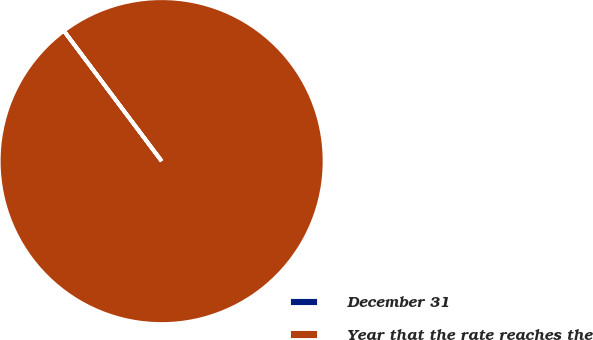Convert chart. <chart><loc_0><loc_0><loc_500><loc_500><pie_chart><fcel>December 31<fcel>Year that the rate reaches the<nl><fcel>0.01%<fcel>99.99%<nl></chart> 